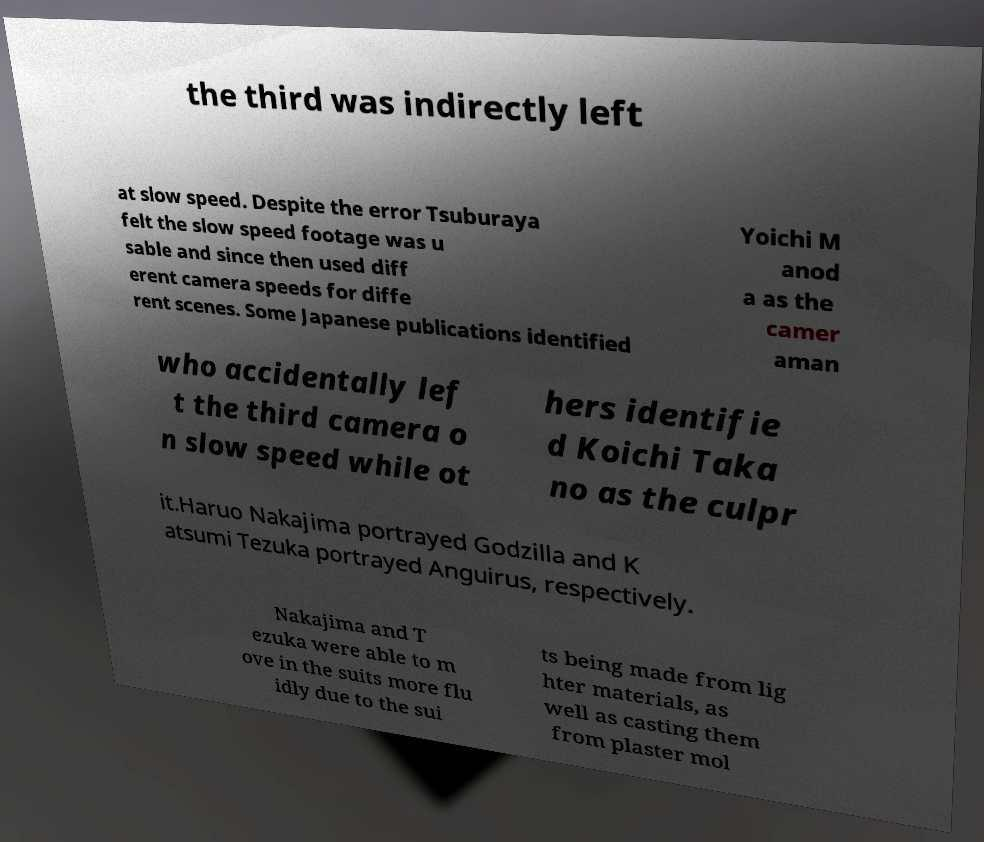Could you extract and type out the text from this image? the third was indirectly left at slow speed. Despite the error Tsuburaya felt the slow speed footage was u sable and since then used diff erent camera speeds for diffe rent scenes. Some Japanese publications identified Yoichi M anod a as the camer aman who accidentally lef t the third camera o n slow speed while ot hers identifie d Koichi Taka no as the culpr it.Haruo Nakajima portrayed Godzilla and K atsumi Tezuka portrayed Anguirus, respectively. Nakajima and T ezuka were able to m ove in the suits more flu idly due to the sui ts being made from lig hter materials, as well as casting them from plaster mol 